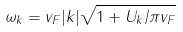Convert formula to latex. <formula><loc_0><loc_0><loc_500><loc_500>\omega _ { k } = v _ { F } | k | \sqrt { 1 + U _ { k } / \pi v _ { F } }</formula> 